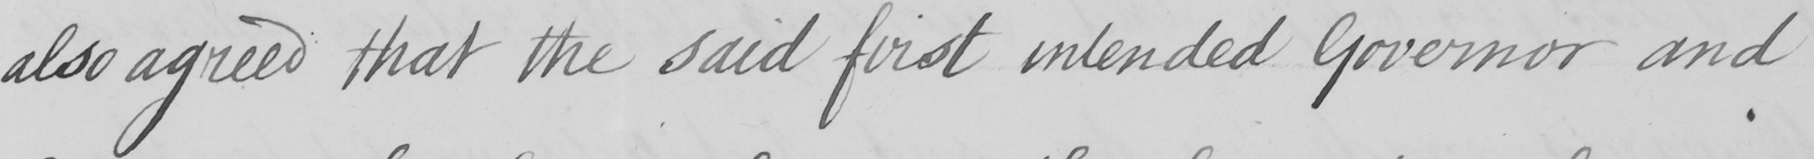Can you tell me what this handwritten text says? also agreed that the said first intended Governor and 